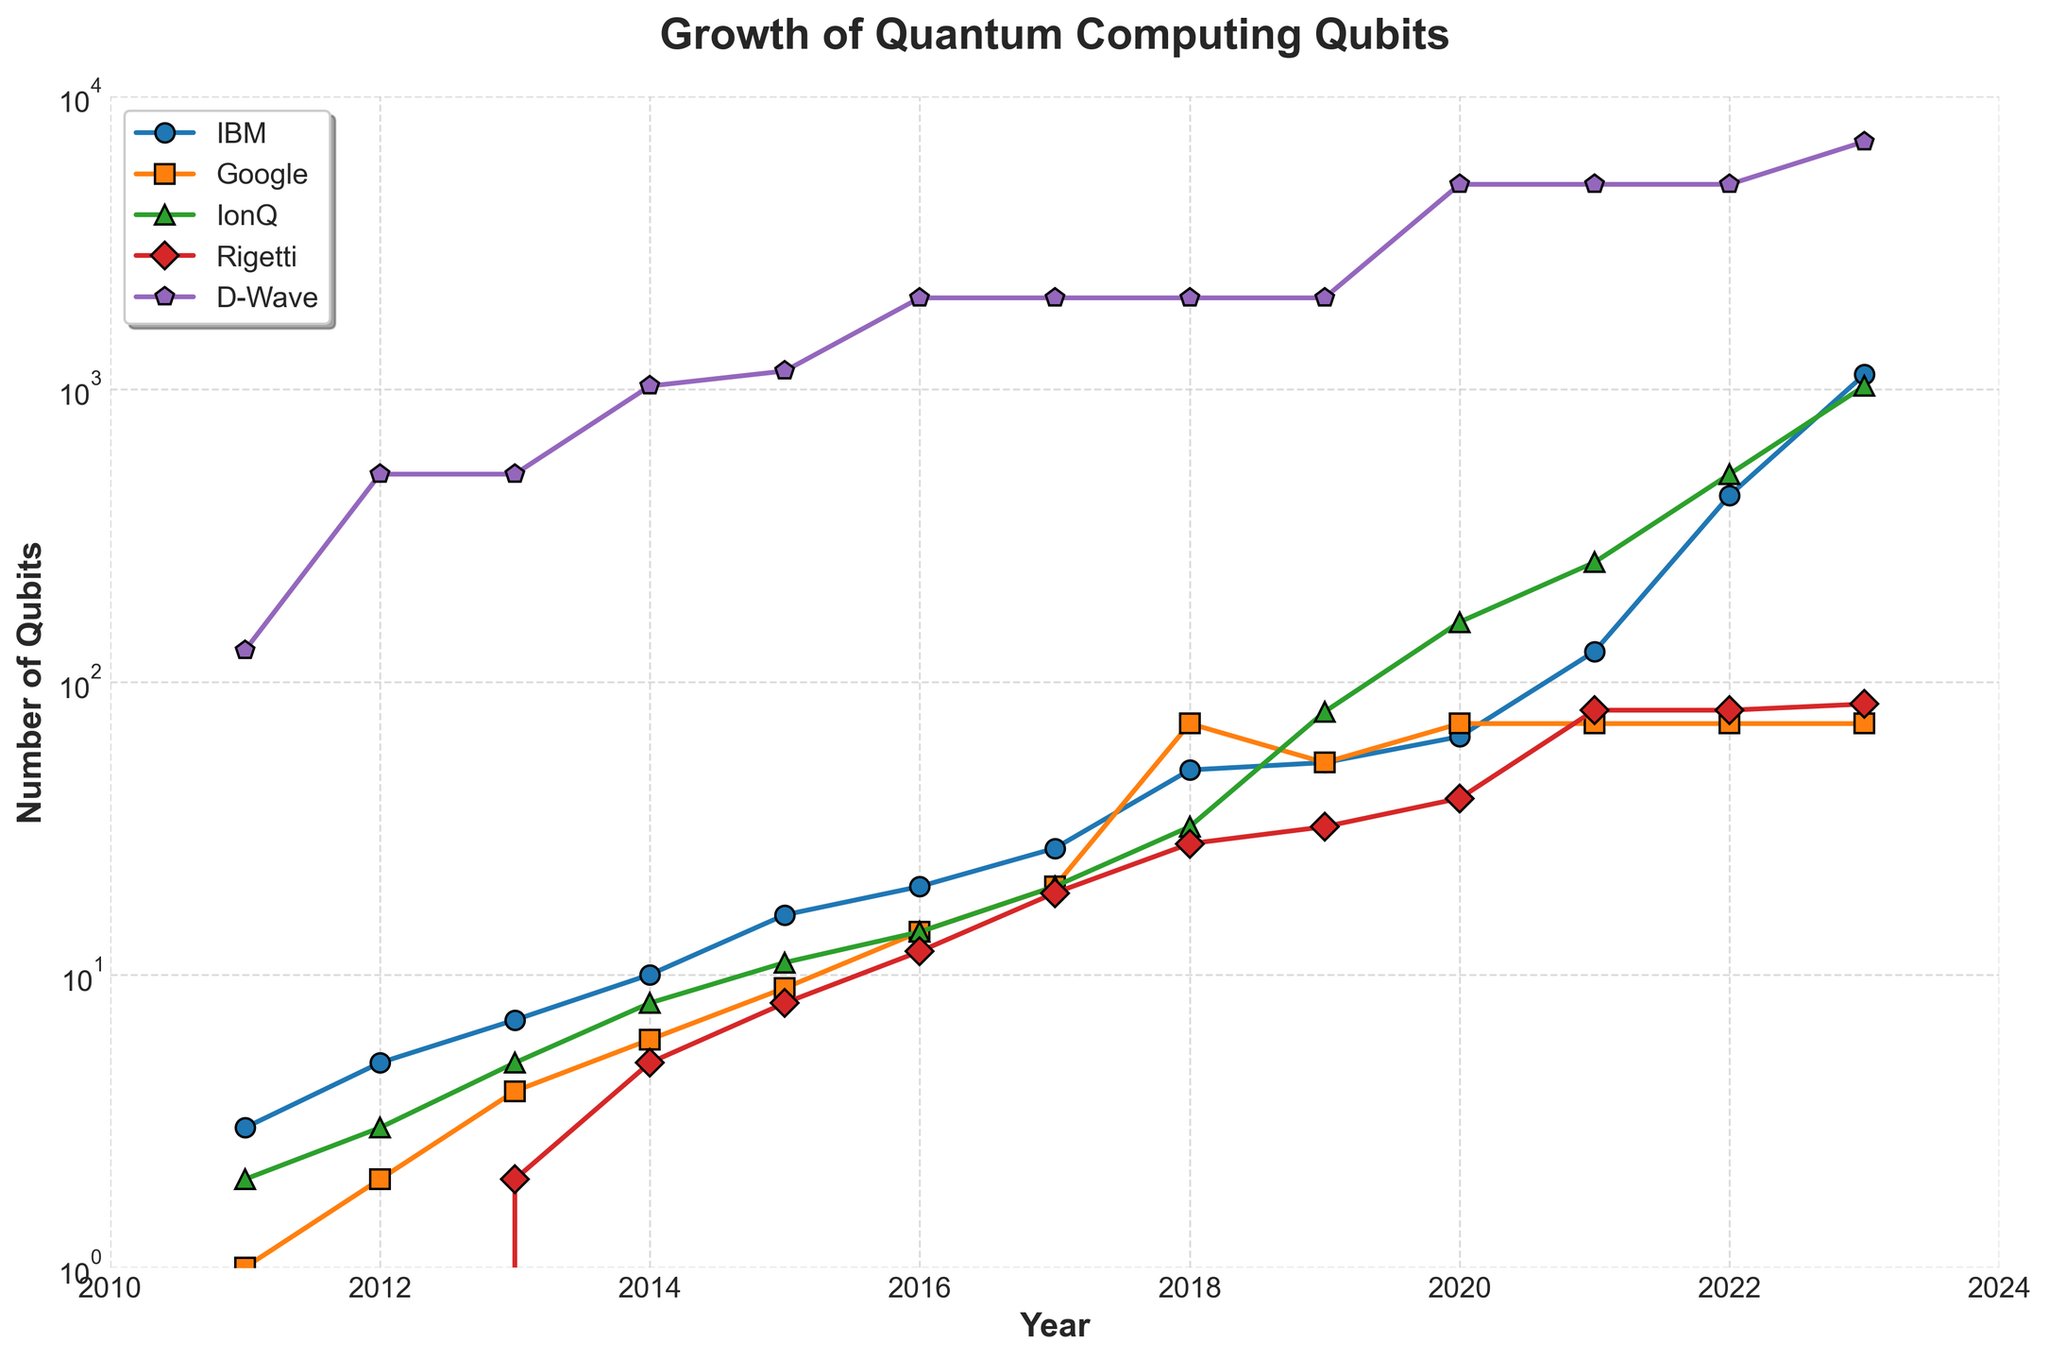What's the highest number of qubits for IBM? IBM's growth is represented by the blue line with circle markers. Looking at the highest point on the IBM line in the most recent year (2023), the value is 1121 qubits.
Answer: 1121 How many more qubits does D-Wave have compared to Google in 2023? D-Wave had 7000 qubits in 2023, while Google had 72 qubits. Subtract Google's qubits from D-Wave's qubits to find the difference: 7000 - 72 = 6928.
Answer: 6928 Which company had the slowest growth in qubits since 2018? Inspect the lines from 2018 onwards. Google’s line, represented by the orange square markers, remained flat at 72 qubits since 2018, indicating the slowest growth.
Answer: Google When was the first year IBM surpassed 100 qubits? Follow IBM's line (blue circles) and find the first year it crosses above 100 qubits, which is in 2021 at 127 qubits.
Answer: 2021 What's the total number of qubits for IonQ from 2017 to 2019? Locate IonQ's line (green triangles) and add the qubits for 2017 (20), 2018 (32), and 2019 (79): 20 + 32 + 79 = 131.
Answer: 131 Did any company have the same number of qubits in 2023 as another company in a previous year? In 2023, Google had 72 qubits, which is the same as its count from 2018 to 2022. No other company matches their 2023 qubit count within the given years.
Answer: No What was the average number of qubits for IBM between 2020 and 2023? Identify IBM's qubits for 2020 (65), 2021 (127), 2022 (433), and 2023 (1121). Sum these values and divide by four: (65 + 127 + 433 + 1121) / 4 = 1746 / 4 = 436.5.
Answer: 436.5 Which platform emerged with its qubits represented by a purple line with pentagon markers? Look for the line represented by purple pentagon markers, which corresponds to D-Wave.
Answer: D-Wave Who had more qubits in 2020: Rigetti or IonQ? By how much? In 2020, Rigetti had 40 qubits, while IonQ had 160 qubits. Subtract Rigetti's qubits from IonQ's qubits: 160 - 40 = 120.
Answer: IonQ by 120 What was the trend for qubits in D-Wave after 2014? D-Wave showed a significant increase in qubits, going from 1024 in 2014 to 7000 in 2023, indicating rapid growth.
Answer: Rapid growth 